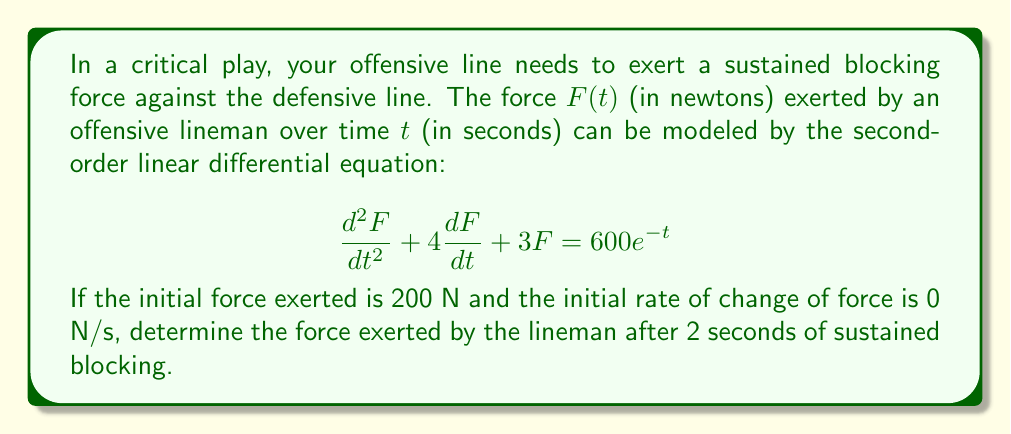Can you answer this question? Let's approach this step-by-step:

1) We have a second-order linear differential equation:
   $$\frac{d^2F}{dt^2} + 4\frac{dF}{dt} + 3F = 600e^{-t}$$

2) The characteristic equation is:
   $$r^2 + 4r + 3 = 0$$

3) Solving this, we get:
   $$r = -1 \text{ or } r = -3$$

4) The complementary solution is:
   $$F_c(t) = c_1e^{-t} + c_2e^{-3t}$$

5) For the particular solution, we guess:
   $$F_p(t) = Ae^{-t}$$

6) Substituting this into the original equation:
   $$A(-1)^2e^{-t} + 4A(-1)e^{-t} + 3Ae^{-t} = 600e^{-t}$$
   $$A - 4A + 3A = 600$$
   $$0 = 600$$
   $$A = 600$$

7) So, the general solution is:
   $$F(t) = c_1e^{-t} + c_2e^{-3t} + 600e^{-t}$$

8) Using the initial conditions:
   $F(0) = 200$, so $c_1 + c_2 + 600 = 200$
   $F'(0) = 0$, so $-c_1 - 3c_2 - 600 = 0$

9) Solving these equations:
   $c_1 = -500$ and $c_2 = 100$

10) Therefore, the particular solution is:
    $$F(t) = -500e^{-t} + 100e^{-3t} + 600e^{-t}$$

11) To find the force after 2 seconds, we calculate $F(2)$:
    $$F(2) = -500e^{-2} + 100e^{-6} + 600e^{-2}$$
    $$= (-500 + 600)e^{-2} + 100e^{-6}$$
    $$= 100e^{-2} + 100e^{-6}$$
    $$\approx 36.97 + 0.25 = 37.22$$
Answer: The force exerted by the lineman after 2 seconds of sustained blocking is approximately 37.22 N. 